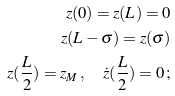Convert formula to latex. <formula><loc_0><loc_0><loc_500><loc_500>z ( 0 ) = z ( L ) = 0 \\ z ( L - \sigma ) = z ( \sigma ) \\ z ( \frac { L } { 2 } ) = z _ { M } \, , \quad \dot { z } ( \frac { L } { 2 } ) = 0 \, ;</formula> 